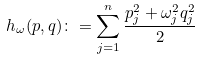Convert formula to latex. <formula><loc_0><loc_0><loc_500><loc_500>h _ { \omega } ( p , q ) \colon = \sum _ { j = 1 } ^ { n } \frac { p _ { j } ^ { 2 } + \omega _ { j } ^ { 2 } q _ { j } ^ { 2 } } { 2 }</formula> 